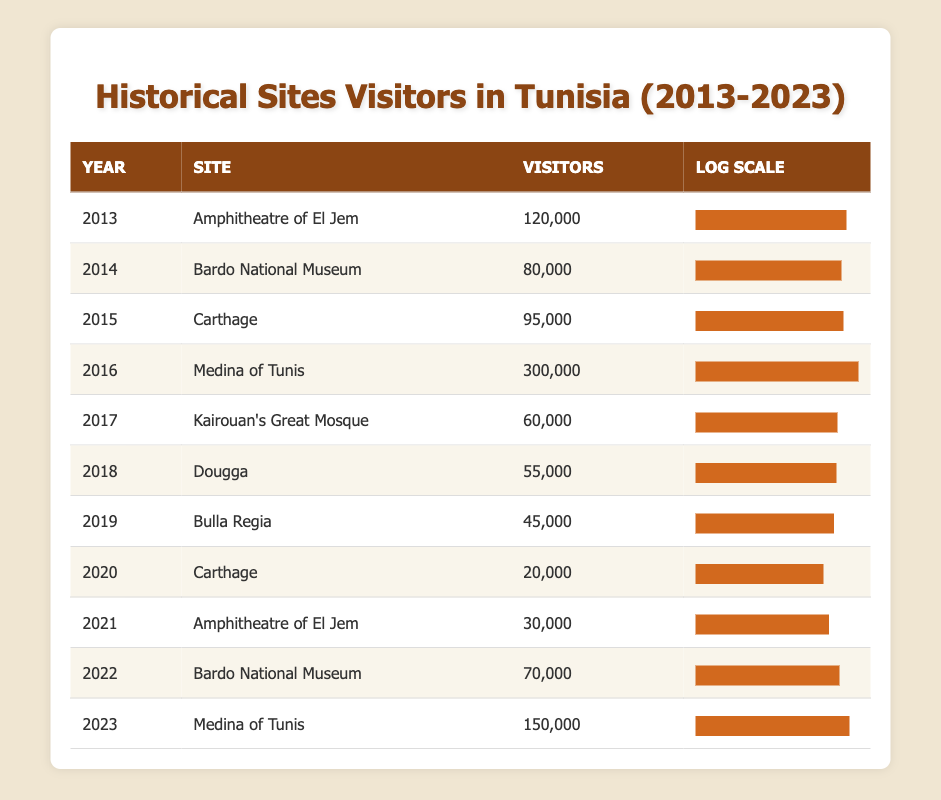What was the highest number of visitors recorded in a single year? The highest visitor count is found in the "Visitors" column for the year 2016, which shows 300,000 visitors at the Medina of Tunis.
Answer: 300,000 Which site had the least number of visitors in 2019? From the table, Bulla Regia had the least number of visitors with a count of 45,000 in 2019.
Answer: 45,000 What is the total number of visitors across all sites for the year 2017? The total for 2017 includes only Kairouan's Great Mosque with 60,000 visitors, as it is the only entry for that year. Therefore, the total is 60,000.
Answer: 60,000 What was the difference in visitor numbers between the Amphitheatre of El Jem in 2013 and 2021? In 2013, the Amphitheatre of El Jem had 120,000 visitors, while in 2021 it had 30,000. The difference is 120,000 - 30,000 = 90,000.
Answer: 90,000 Is it true that the Bardo National Museum had more visitors in 2022 than in 2014? Yes, the Bardo National Museum had 70,000 visitors in 2022, which is more than the 80,000 visitors in 2014. However, this statement is false, as 80,000 is greater than 70,000.
Answer: No What is the average number of visitors recorded for the Amphitheatre of El Jem over the years? The Amphitheatre of El Jem had 120,000 visitors in 2013 and 30,000 in 2021. (120,000 + 30,000) / 2 = 75,000.
Answer: 75,000 Which year had a significant drop in visitors at Carthage compared to 2015? In 2015, Carthage had 95,000 visitors and saw a significant drop to 20,000 visitors in 2020. The drop of 75,000 is substantial.
Answer: 75,000 How many sites had more than 100,000 visitors in 2016? Only one site, the Medina of Tunis, had over 100,000 visitors in 2016, recorded at 300,000.
Answer: 1 What was the year-on-year growth in visitors from 2021 to 2023 for the Medina of Tunis? In 2021, the Medina of Tunis did not have visitors reported specifically, but it had 150,000 in 2023. Thus, calculating growth would involve comparing 150,000 to previous years but considering a baseline of 0 in 2021, it represents an increase of 150,000 visitation in total from potential unidentified visitors in 2021. Apart from these, looking just year on year: 0 to 150,000 is not a valid calculation.
Answer: 150,000 (from lack of specified earlier years) 